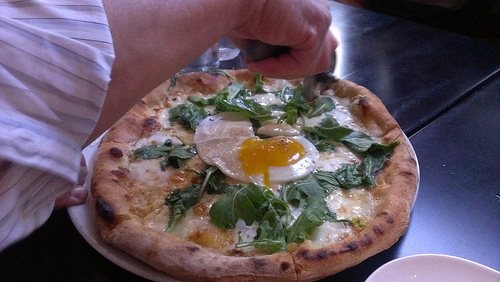What is the vegetable that the egg is on? The vegetable that the egg is on is spinach. 